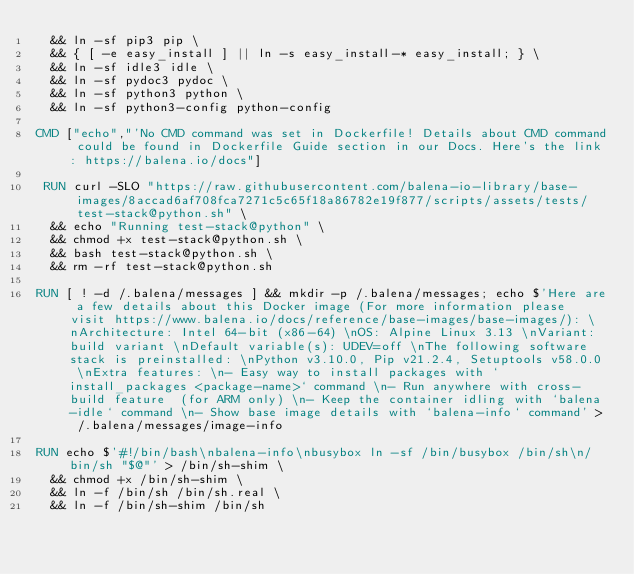<code> <loc_0><loc_0><loc_500><loc_500><_Dockerfile_>	&& ln -sf pip3 pip \
	&& { [ -e easy_install ] || ln -s easy_install-* easy_install; } \
	&& ln -sf idle3 idle \
	&& ln -sf pydoc3 pydoc \
	&& ln -sf python3 python \
	&& ln -sf python3-config python-config

CMD ["echo","'No CMD command was set in Dockerfile! Details about CMD command could be found in Dockerfile Guide section in our Docs. Here's the link: https://balena.io/docs"]

 RUN curl -SLO "https://raw.githubusercontent.com/balena-io-library/base-images/8accad6af708fca7271c5c65f18a86782e19f877/scripts/assets/tests/test-stack@python.sh" \
  && echo "Running test-stack@python" \
  && chmod +x test-stack@python.sh \
  && bash test-stack@python.sh \
  && rm -rf test-stack@python.sh 

RUN [ ! -d /.balena/messages ] && mkdir -p /.balena/messages; echo $'Here are a few details about this Docker image (For more information please visit https://www.balena.io/docs/reference/base-images/base-images/): \nArchitecture: Intel 64-bit (x86-64) \nOS: Alpine Linux 3.13 \nVariant: build variant \nDefault variable(s): UDEV=off \nThe following software stack is preinstalled: \nPython v3.10.0, Pip v21.2.4, Setuptools v58.0.0 \nExtra features: \n- Easy way to install packages with `install_packages <package-name>` command \n- Run anywhere with cross-build feature  (for ARM only) \n- Keep the container idling with `balena-idle` command \n- Show base image details with `balena-info` command' > /.balena/messages/image-info

RUN echo $'#!/bin/bash\nbalena-info\nbusybox ln -sf /bin/busybox /bin/sh\n/bin/sh "$@"' > /bin/sh-shim \
	&& chmod +x /bin/sh-shim \
	&& ln -f /bin/sh /bin/sh.real \
	&& ln -f /bin/sh-shim /bin/sh</code> 